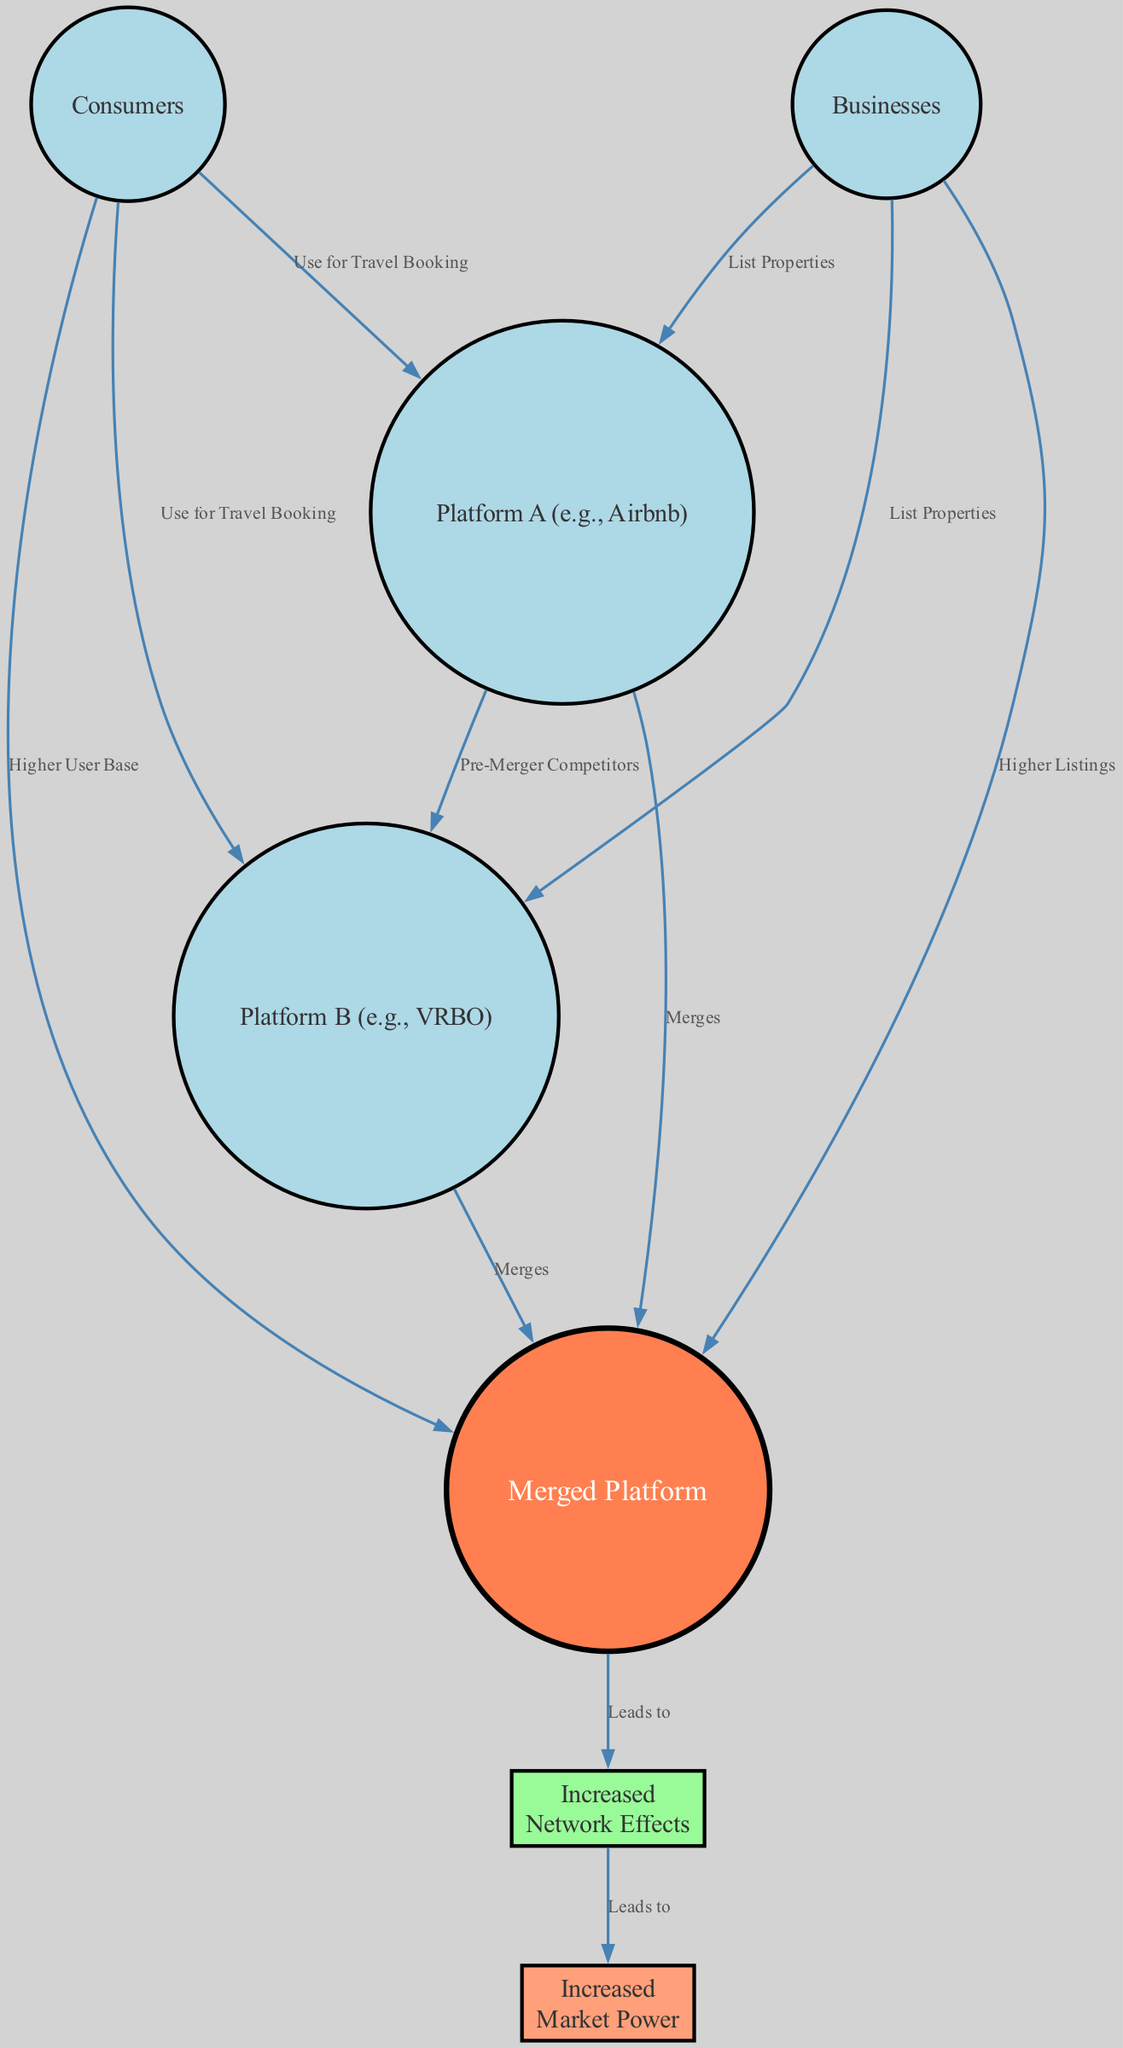What are the types of nodes in the diagram? The diagram contains two types of nodes: circular nodes representing "Consumers," "Businesses," "Platform A," "Platform B," and the "Merged Platform," and square nodes for "Increased Network Effects" and "Increased Market Power." Thus, the two types of nodes are "circle" and "square."
Answer: circle and square How many nodes are there in total? By counting all nodes listed in the data, we find six circular nodes ("Consumers," "Businesses," "Platform A," "Platform B," "Merged Platform") and two square nodes ("Increased Network Effects" and "Increased Market Power"), resulting in a total of eight nodes.
Answer: eight What is the relationship between "Consumers" and "Platform A"? There is a direct link from "Consumers" to "Platform A," indicating that consumers use it for travel booking. This relationship is depicted on the edge connecting the nodes with the label "Use for Travel Booking."
Answer: Use for Travel Booking What leads to "Increased Network Effects"? The "Merged Platform" node leads to "Increased Network Effects," indicating that the merger of Platform A and Platform B results in enhanced network effects on the new merged platform. This is shown on the arrow originating from the "Merged Platform" pointing to "Increased Network Effects" labeled "Leads to."
Answer: Merged Platform How does "Increased Network Effects" impact "Market Power"? "Increased Network Effects" leads to "Increased Market Power," suggesting that as network effects strengthen, the market power of the merged entity also increases. This connection is clearly marked by an arrow with the label "Leads to."
Answer: Leads to What indicates that "Consumers" and "Businesses" both contribute to the "Merged Platform"? There are two separate connections: one from "Consumers" to "Merged Platform" labeled "Higher User Base" and another from "Businesses" to "Merged Platform" labeled "Higher Listings," indicating that both consumers and businesses contribute to enhancing the merged platform.
Answer: Higher User Base and Higher Listings Which two platforms are listed as pre-merger competitors? The diagram specifies "Platform A" and "Platform B" as pre-merger competitors, connected by an edge labeled "Pre-Merger Competitors." This implies they operate in the same market before the merger occurs.
Answer: Platform A and Platform B What does the square node "Market Power" represent in terms of the merger's effect? The square node "Market Power" represents the increased influence and control over the market that the newly formed "Merged Platform" gains as a direct consequence of enhanced network effects, highlighted in the flow of the diagram.
Answer: Increased Market Power 